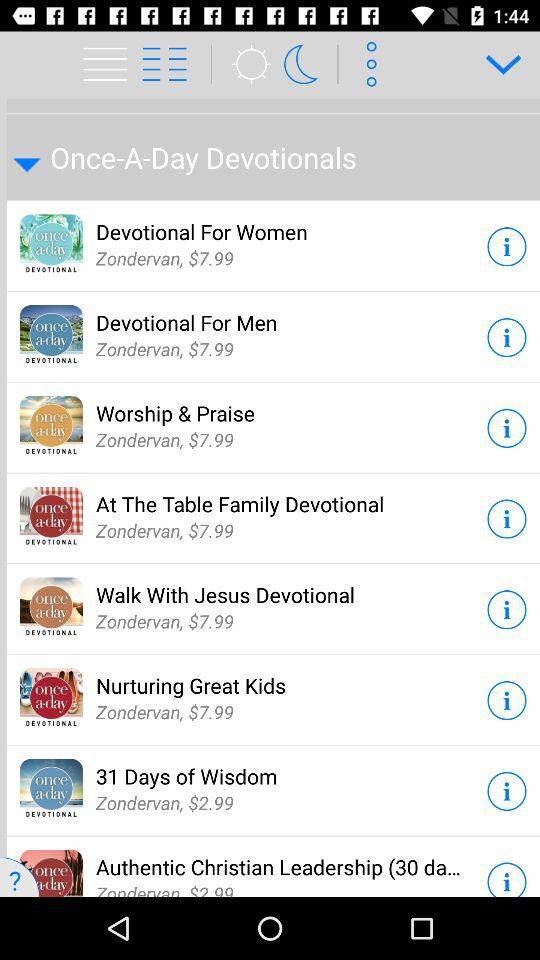How many devotionals are priced at $2.99?
Answer the question using a single word or phrase. 2 